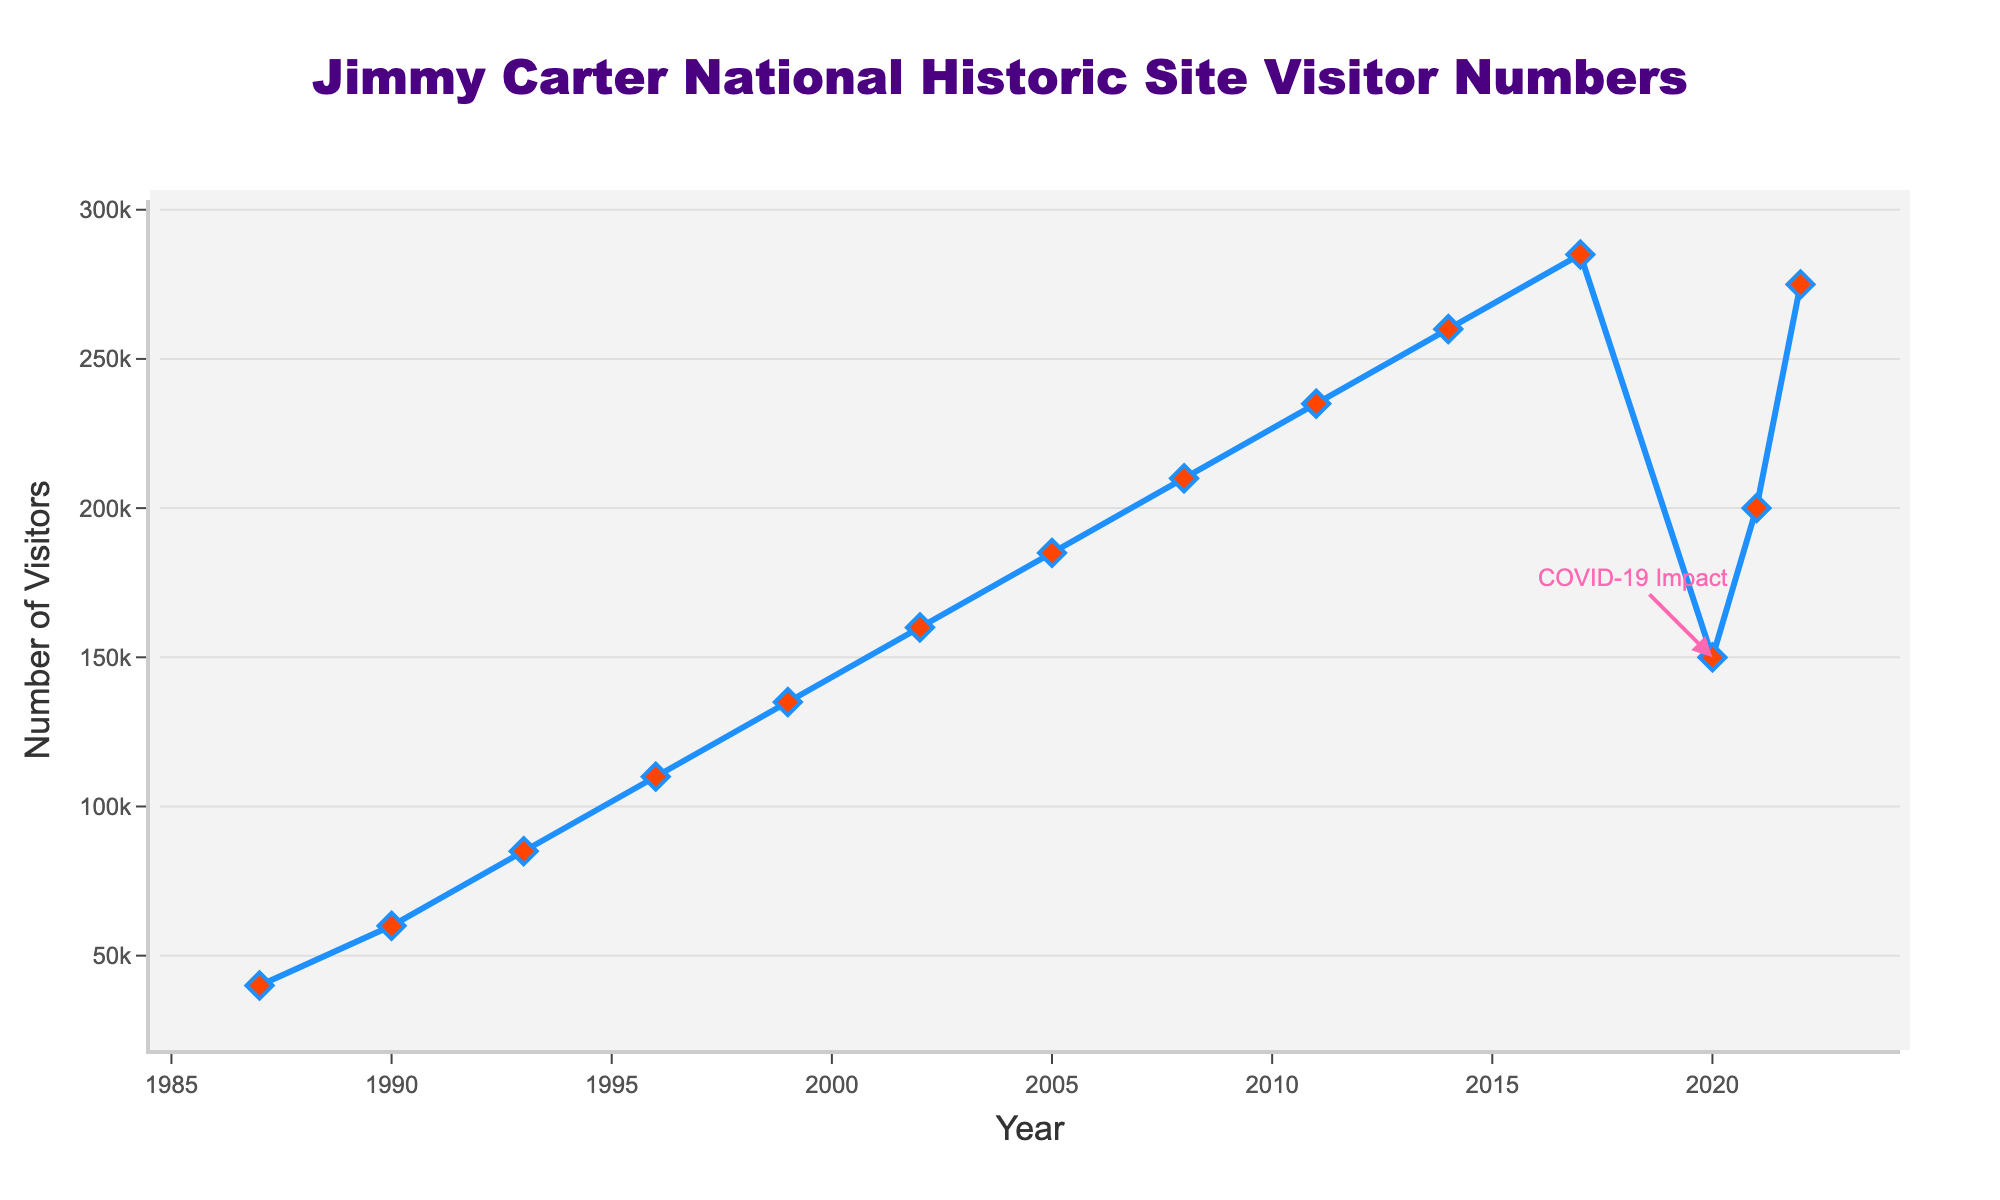How did the visitor numbers change from 1987 to 1990? The visitor numbers increased from 40,000 in 1987 to 60,000 in 1990, which is a difference of 20,000.
Answer: Increased by 20,000 What were the visitor numbers in the years when they reached 100,000 or more? The visitor numbers were 110,000 in 1996, 135,000 in 1999, 160,000 in 2002, 185,000 in 2005, 210,000 in 2008, 235,000 in 2011, 260,000 in 2014, 285,000 in 2017, 150,000 in 2020, 200,000 in 2021, and 275,000 in 2022.
Answer: 1996, 1999, 2002, 2005, 2008, 2011, 2014, 2017, 2020, 2021, 2022 Which year had the highest number of visitors and how many visitors were there? The highest number of visitors was in 2017, with 285,000 visitors.
Answer: 2017, 285,000 visitors What is the average number of visitors from 1987 to 2022 excluding 2020? Adding the visitor numbers for all years except 2020 gives 2,080,000. There are 13 years, so the average is 2,080,000/13 = 160,000.
Answer: 160,000 What visual element indicates the impact of COVID-19 on visitor numbers? There is an annotation with text "COVID-19 Impact" pointing to the visitor numbers for the year 2020, which shows a significant drop.
Answer: The annotation Which year saw the largest increase in visitor numbers compared to the previous year? The largest increase is from 2021 to 2022, where the visitor numbers went from 200,000 to 275,000, an increase of 75,000.
Answer: 2021 to 2022 How many years did it take for visitor numbers to rise from 40,000 to over 250,000? The visitor numbers rose from 40,000 in 1987 to 260,000 in 2014, which took 27 years.
Answer: 27 years 